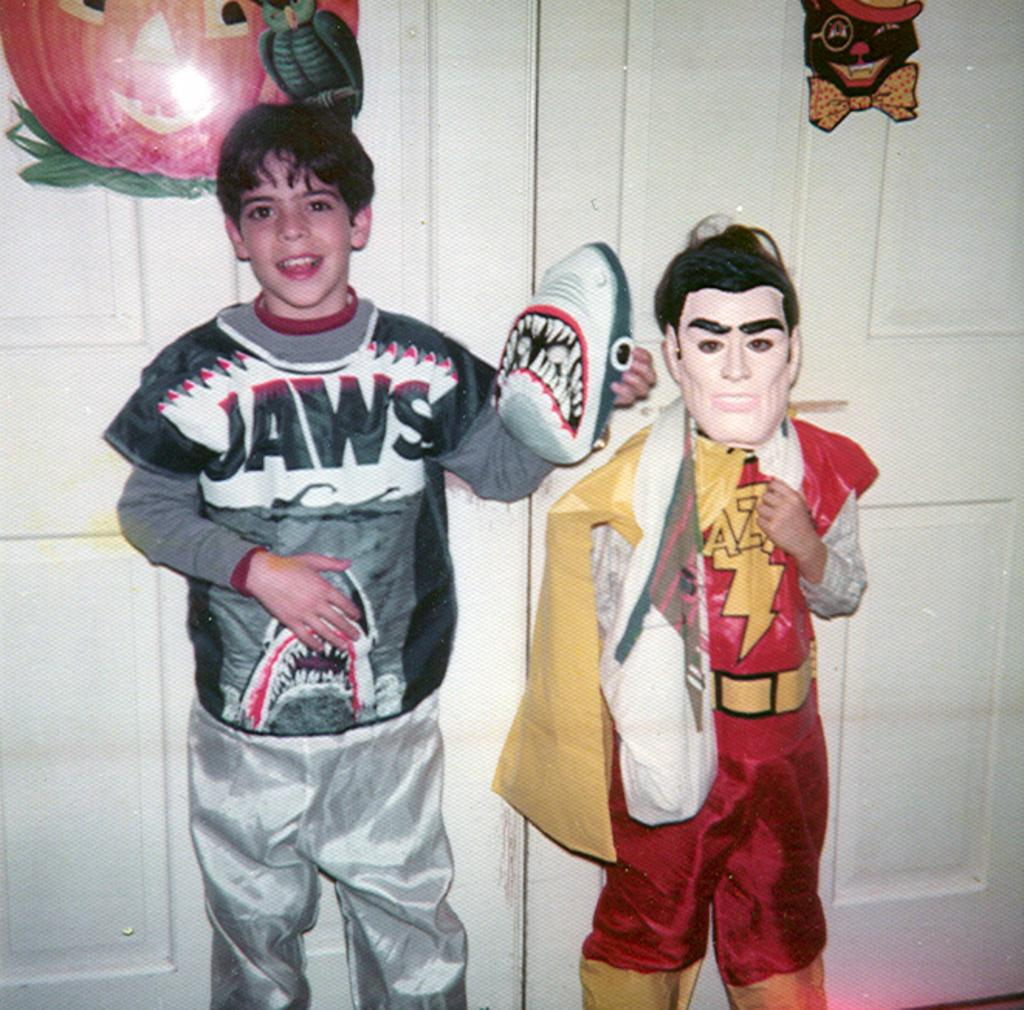<image>
Give a short and clear explanation of the subsequent image. the word jaws is on the shirt of a person 